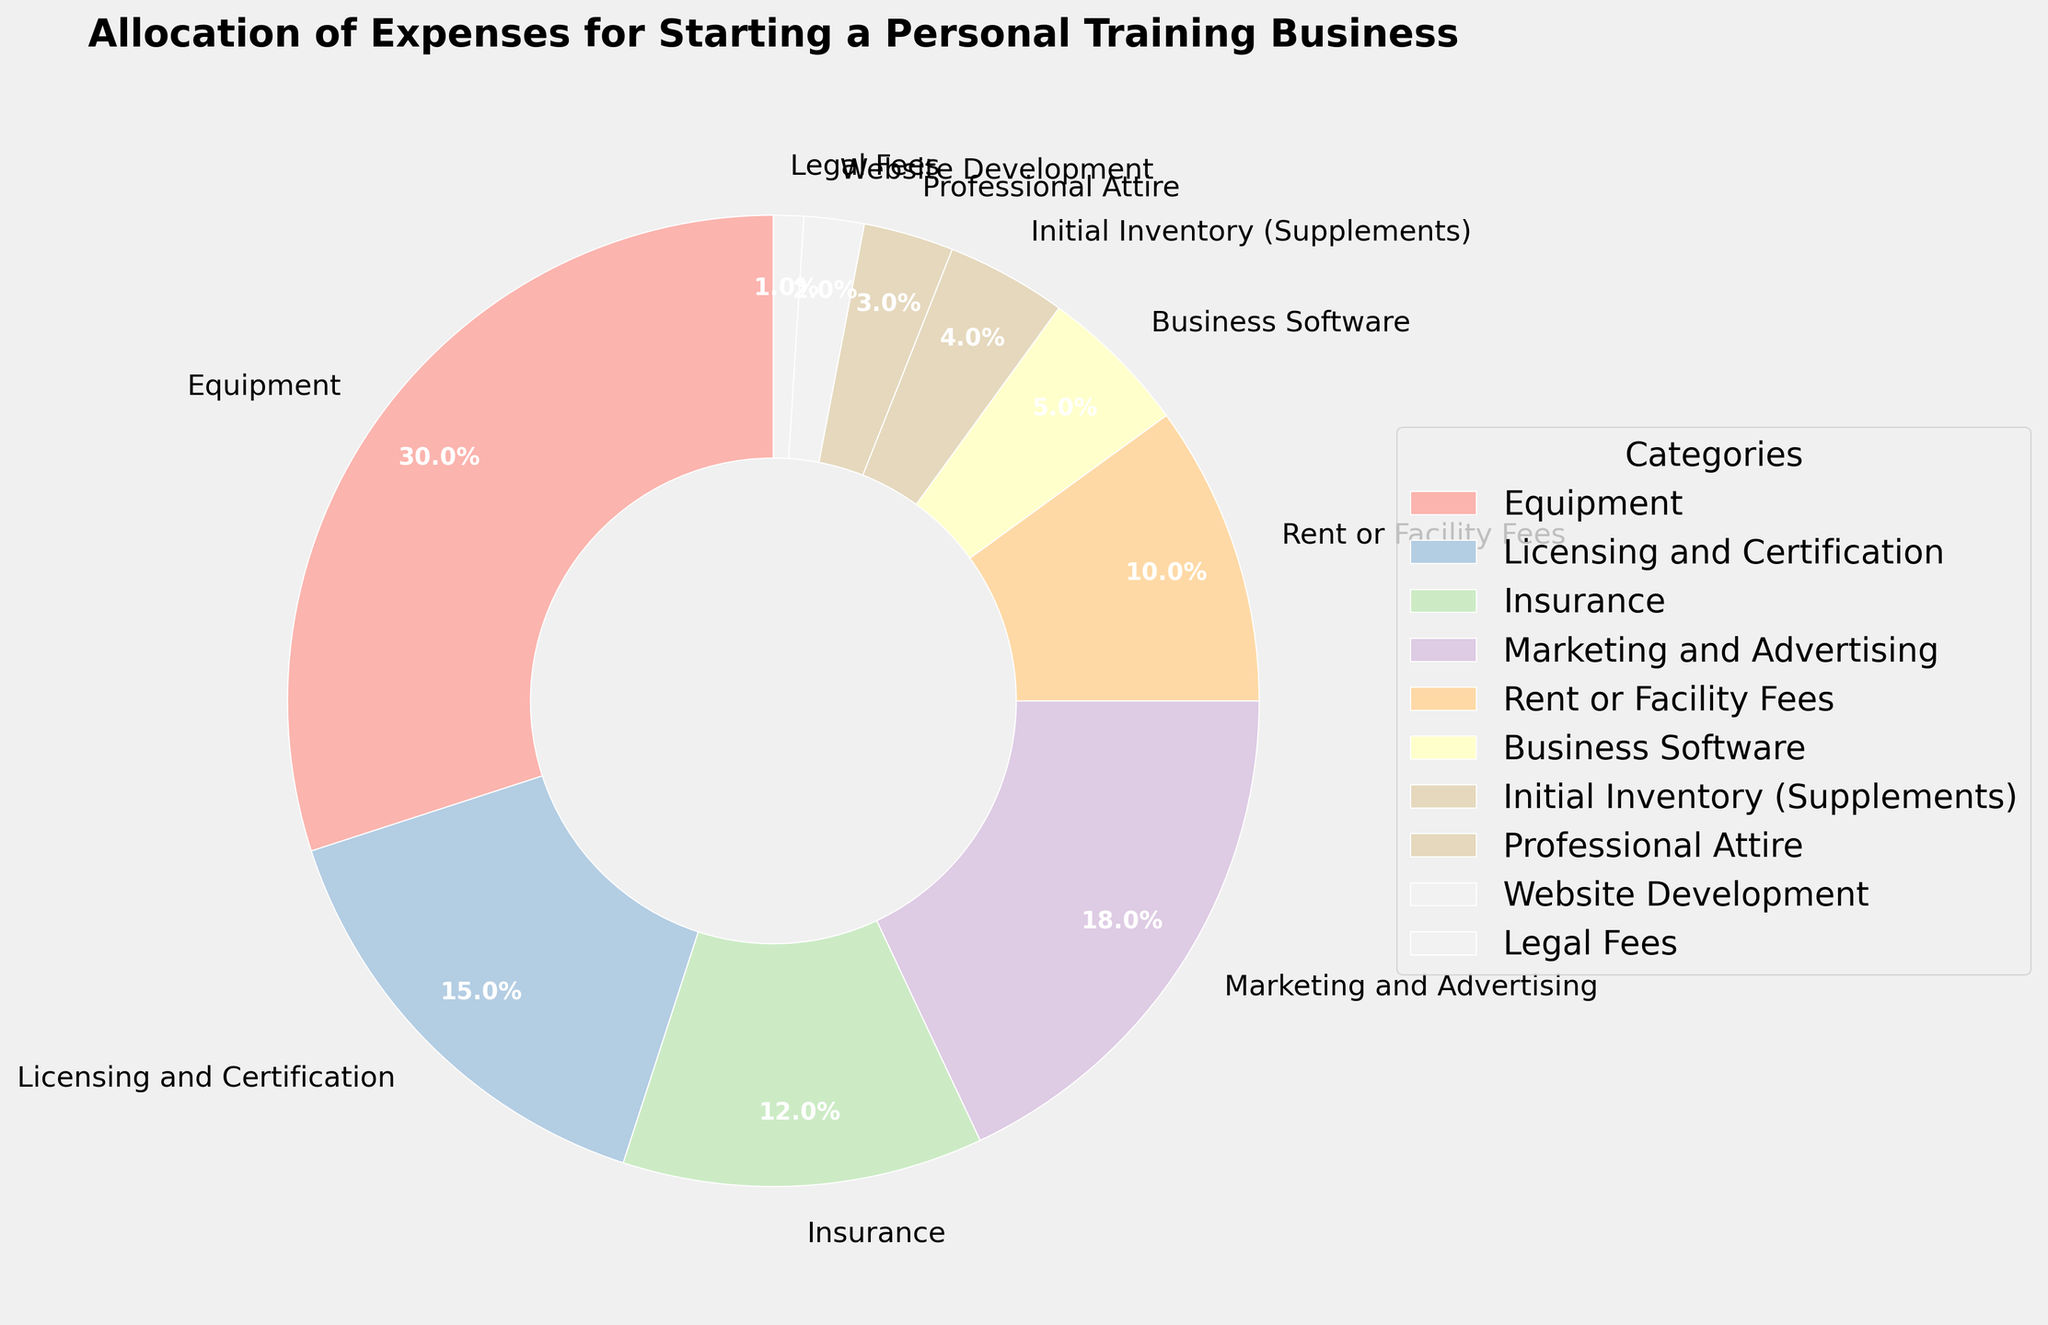What is the largest expense category for starting a personal training business? Looking at the pie chart, it's evident that the largest wedge or segment corresponds to 'Equipment' with a percentage of 30%.
Answer: Equipment Which expense category is larger: Marketing and Advertising or Legal Fees? By comparing the sizes of the pie chart segments, Marketing and Advertising has 18% while Legal Fees has only 1%. Therefore, Marketing and Advertising is larger.
Answer: Marketing and Advertising What is the total percentage allocated to Licensing and Certification, and Insurance combined? Licensing and Certification is 15% and Insurance is 12%. Adding these gives 15% + 12% = 27%.
Answer: 27% How much more is spent on Rent or Facility Fees compared to Professional Attire? Rent or Facility Fees is 10% and Professional Attire is 3%. The difference is 10% - 3% = 7%.
Answer: 7% Which categories together make up over 50% of the total expenses? Equipment (30%), Licensing and Certification (15%), and Marketing and Advertising (18%) alone already surpass 50%. Their combined total is 30% + 15% + 18% = 63%.
Answer: Equipment, Licensing and Certification, Marketing and Advertising How does the allocation for Business Software compare to Initial Inventory (Supplements)? Business Software is 5% and Initial Inventory (Supplements) is 4%. Business Software's percentage is larger.
Answer: Business Software What is the percentage difference between Marketing and Advertising and Insurance? Marketing and Advertising is 18%, Insurance is 12%. The percentage difference is calculated as 18% - 12% = 6%.
Answer: 6% What is the total percentage of the least three expense categories? The least three categories are Legal Fees (1%), Website Development (2%), and Professional Attire (3%). Adding them gives 1% + 2% + 3% = 6%.
Answer: 6% Which category accounts for exactly 10% of the total expenses? Looking at the pie chart, Rent or Facility Fees is the category that has been allocated 10%.
Answer: Rent or Facility Fees 